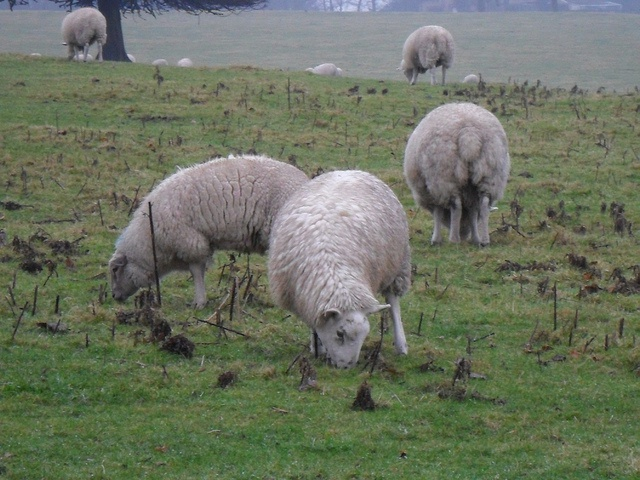Describe the objects in this image and their specific colors. I can see sheep in darkblue, darkgray, gray, and lightgray tones, sheep in darkblue, gray, darkgray, and black tones, sheep in darkblue, darkgray, gray, and black tones, sheep in darkblue, darkgray, and gray tones, and sheep in darkblue, gray, darkgray, and black tones in this image. 